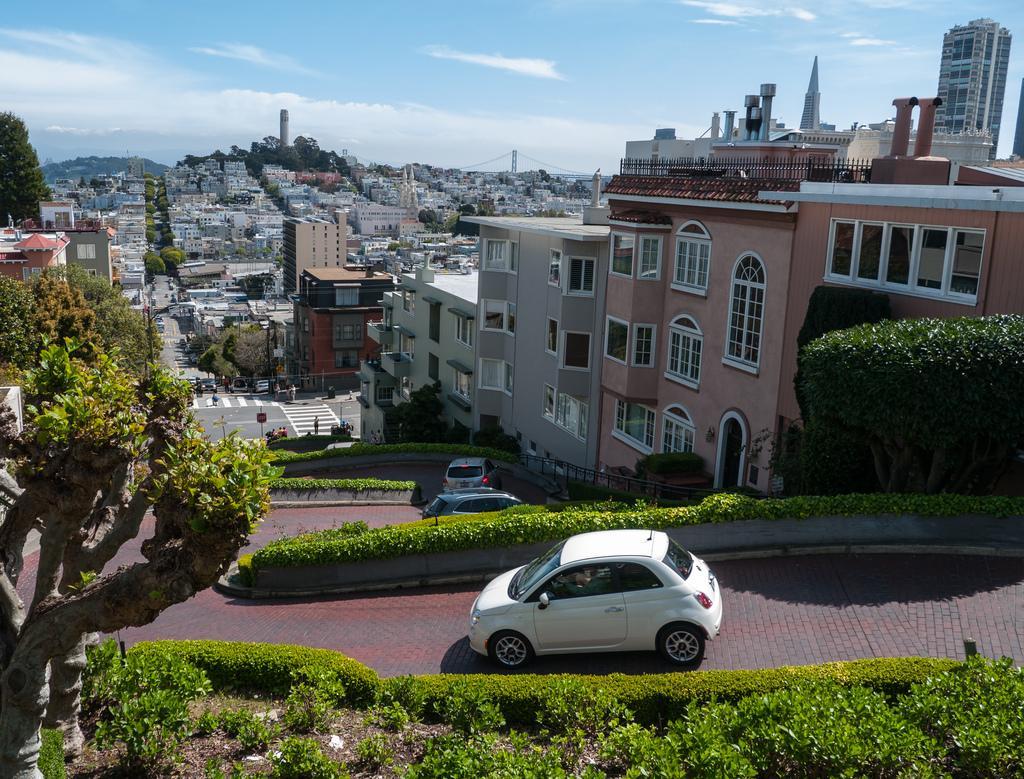In one or two sentences, can you explain what this image depicts? In this image I can see few vehicles, in front the vehicle is in white color, I can see trees in green color. Background I can see few buildings in peach, gray, brown and cream color, and the sky is in white and blue color. 